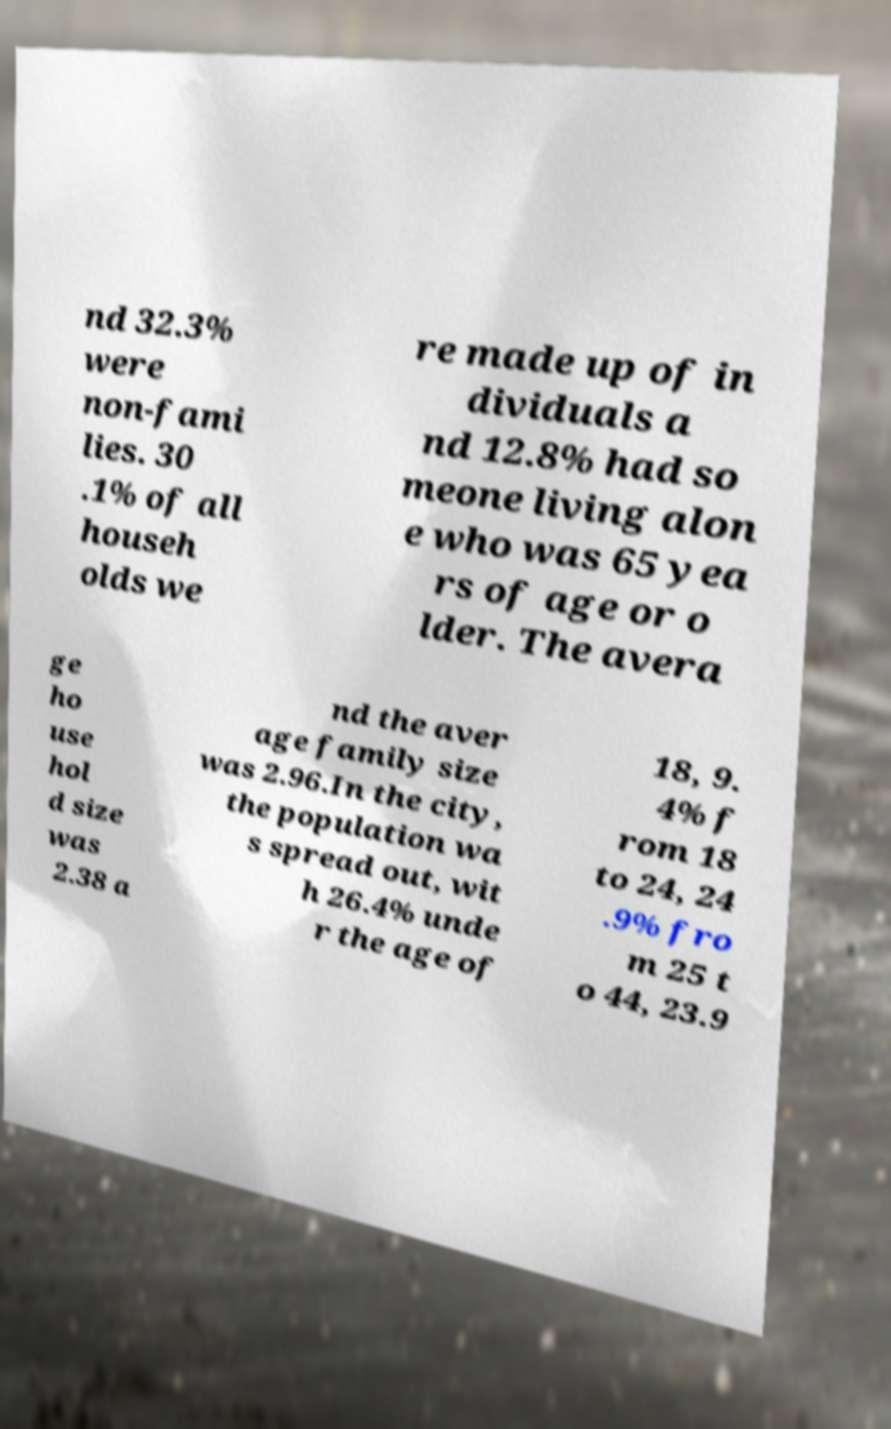Could you assist in decoding the text presented in this image and type it out clearly? nd 32.3% were non-fami lies. 30 .1% of all househ olds we re made up of in dividuals a nd 12.8% had so meone living alon e who was 65 yea rs of age or o lder. The avera ge ho use hol d size was 2.38 a nd the aver age family size was 2.96.In the city, the population wa s spread out, wit h 26.4% unde r the age of 18, 9. 4% f rom 18 to 24, 24 .9% fro m 25 t o 44, 23.9 